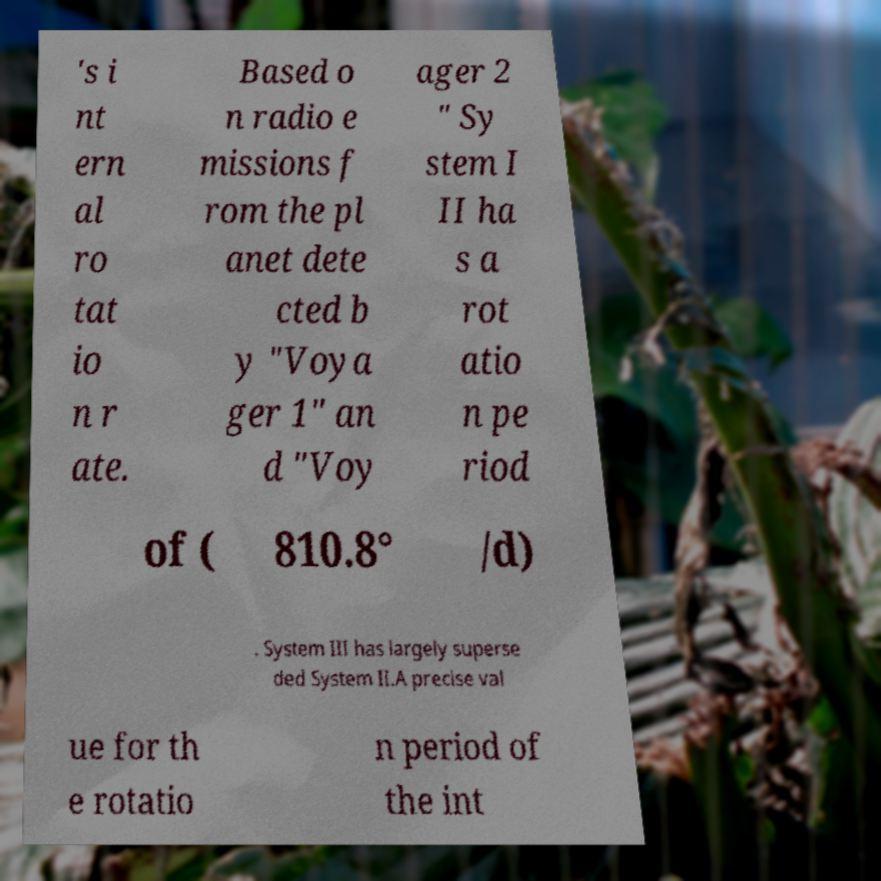Can you read and provide the text displayed in the image?This photo seems to have some interesting text. Can you extract and type it out for me? 's i nt ern al ro tat io n r ate. Based o n radio e missions f rom the pl anet dete cted b y "Voya ger 1" an d "Voy ager 2 " Sy stem I II ha s a rot atio n pe riod of ( 810.8° /d) . System III has largely superse ded System II.A precise val ue for th e rotatio n period of the int 